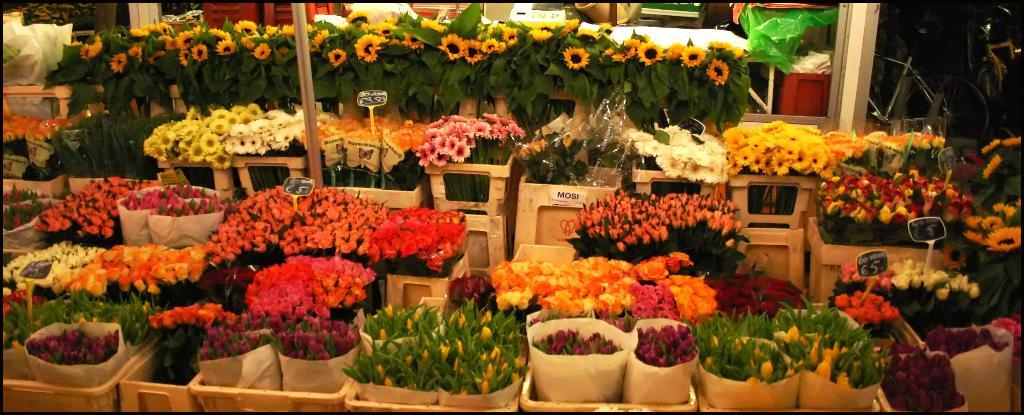What type of plants can be seen in the image? There is a group of flowers in the image. What objects are used for holding or storing items in the image? Containers are present in the image. What vertical structure can be seen in the image? A pole is present in the image. What type of surface is visible in the image? Boards are visible in the image. What is used to protect or conceal something in the image? There is a cover in the image. What type of writing material is present in the image? Paper is present in the image. What type of support structure is visible in the image? A stand is visible in the image. What mode of transportation can be seen in the top right corner of the image? There is a bicycle in the top right corner of the image. Where is the tray located in the image? There is no tray present in the image. What type of vegetable is visible in the image? There is no pickle or any vegetable visible in the image. What type of horizontal support structure is visible in the image? There is no beam present in the image. 